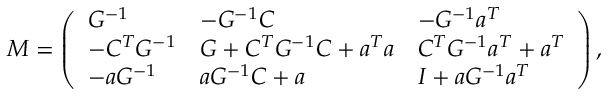<formula> <loc_0><loc_0><loc_500><loc_500>M = \left ( \begin{array} { l l l } { { G ^ { - 1 } } } & { { - G ^ { - 1 } C } } & { { - G ^ { - 1 } a ^ { T } } } \\ { { - C ^ { T } G ^ { - 1 } } } & { { G + C ^ { T } G ^ { - 1 } C + a ^ { T } a } } & { { C ^ { T } G ^ { - 1 } a ^ { T } + a ^ { T } } } \\ { { - a G ^ { - 1 } } } & { { a G ^ { - 1 } C + a } } & { { I + a G ^ { - 1 } a ^ { T } } } \end{array} \right ) ,</formula> 